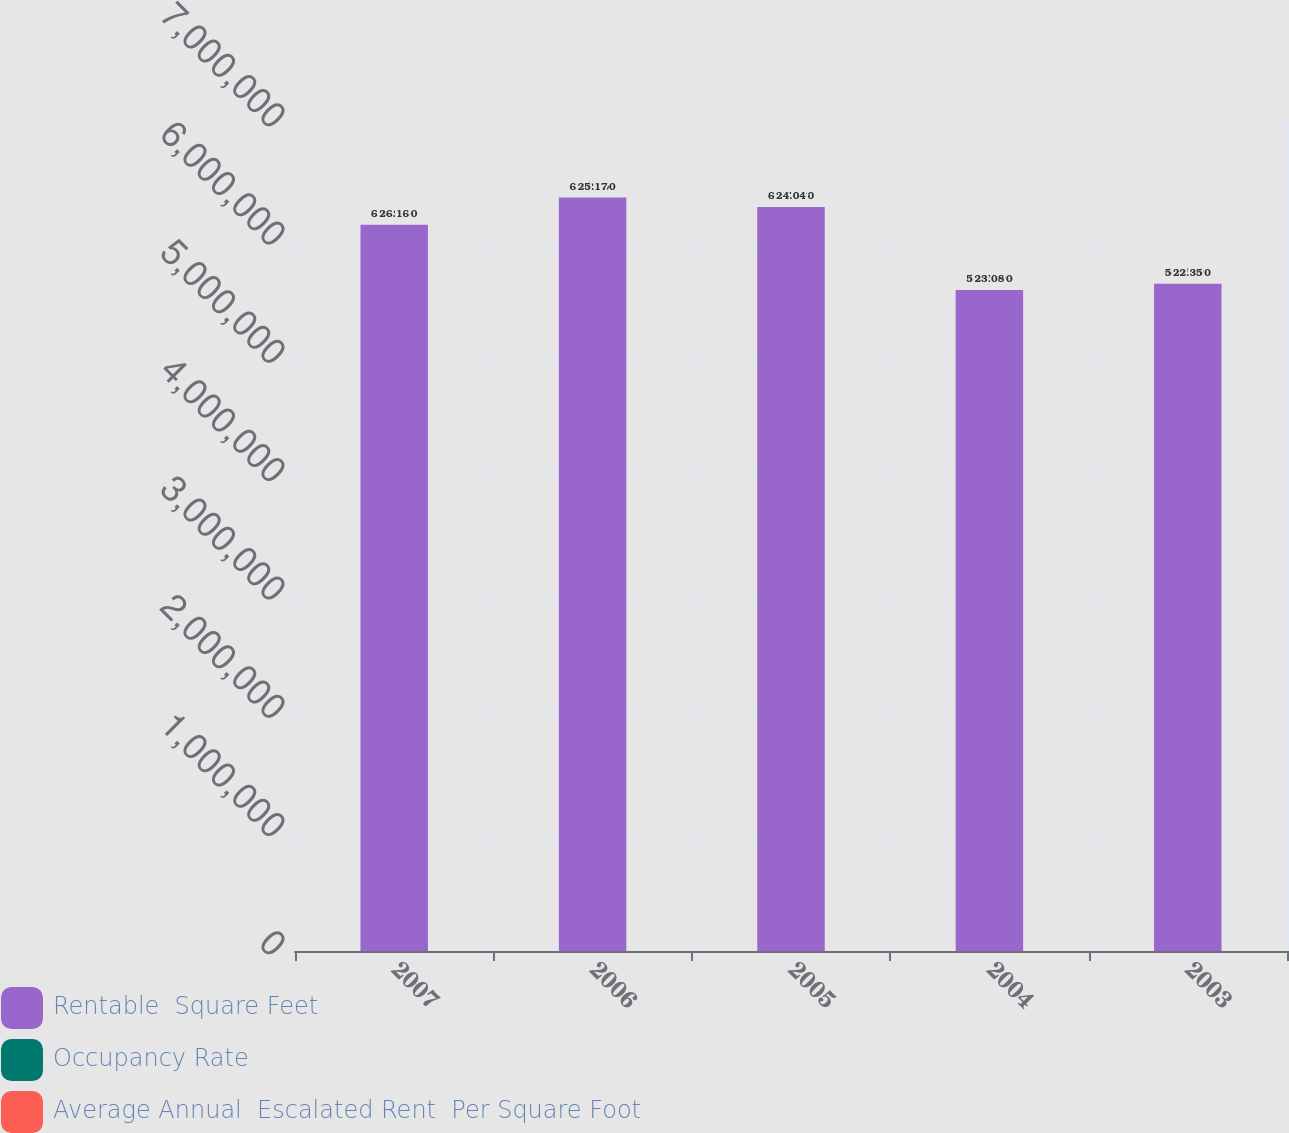Convert chart to OTSL. <chart><loc_0><loc_0><loc_500><loc_500><stacked_bar_chart><ecel><fcel>2007<fcel>2006<fcel>2005<fcel>2004<fcel>2003<nl><fcel>Rentable  Square Feet<fcel>6.139e+06<fcel>6.37e+06<fcel>6.29e+06<fcel>5.589e+06<fcel>5.64e+06<nl><fcel>Occupancy Rate<fcel>93.7<fcel>93.6<fcel>94.7<fcel>97.6<fcel>95.1<nl><fcel>Average Annual  Escalated Rent  Per Square Foot<fcel>26.16<fcel>25.17<fcel>24.04<fcel>23.08<fcel>22.35<nl></chart> 